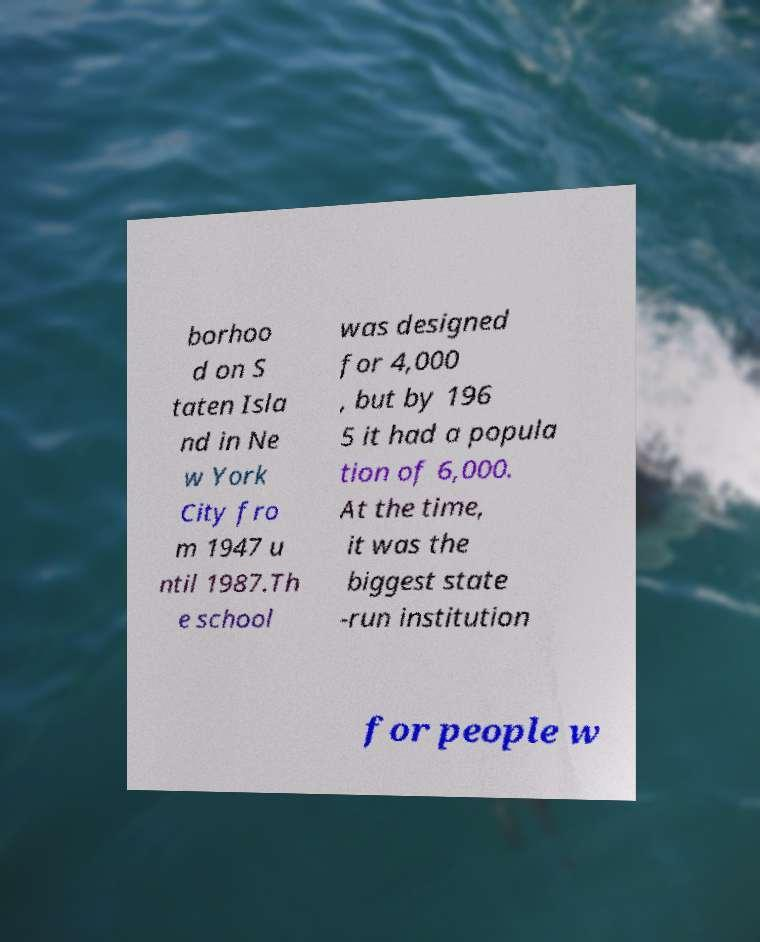Could you extract and type out the text from this image? borhoo d on S taten Isla nd in Ne w York City fro m 1947 u ntil 1987.Th e school was designed for 4,000 , but by 196 5 it had a popula tion of 6,000. At the time, it was the biggest state -run institution for people w 